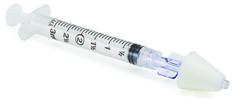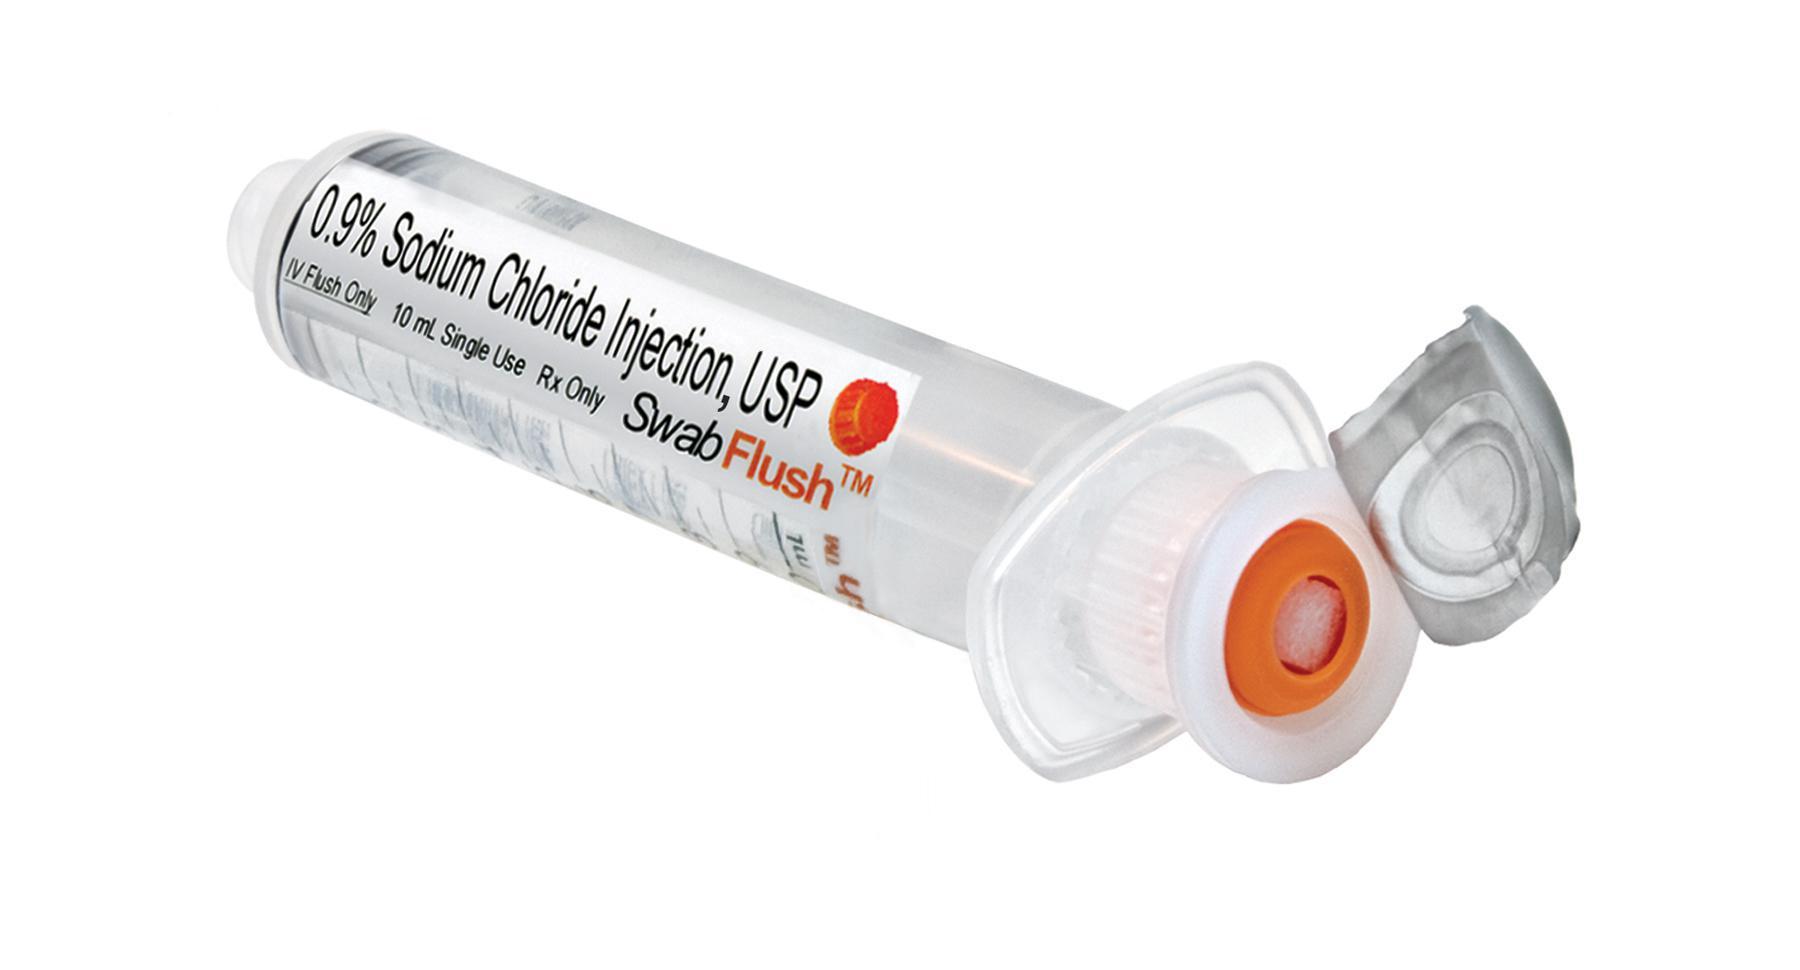The first image is the image on the left, the second image is the image on the right. Examine the images to the left and right. Is the description "In one image, the sharp end of a needle is enclosed in a cone-shaped plastic tip." accurate? Answer yes or no. Yes. 